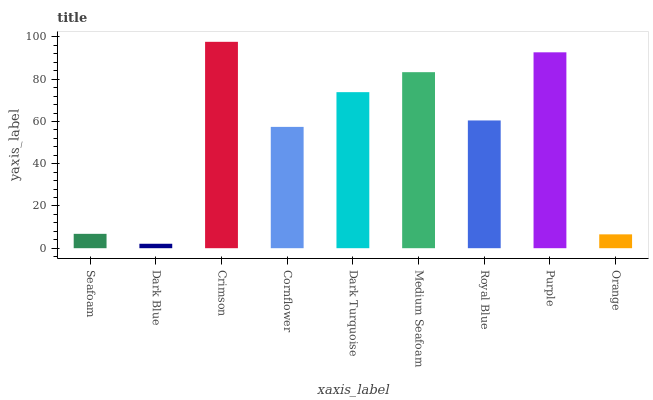Is Crimson the minimum?
Answer yes or no. No. Is Dark Blue the maximum?
Answer yes or no. No. Is Crimson greater than Dark Blue?
Answer yes or no. Yes. Is Dark Blue less than Crimson?
Answer yes or no. Yes. Is Dark Blue greater than Crimson?
Answer yes or no. No. Is Crimson less than Dark Blue?
Answer yes or no. No. Is Royal Blue the high median?
Answer yes or no. Yes. Is Royal Blue the low median?
Answer yes or no. Yes. Is Seafoam the high median?
Answer yes or no. No. Is Medium Seafoam the low median?
Answer yes or no. No. 